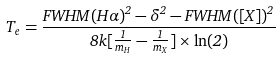Convert formula to latex. <formula><loc_0><loc_0><loc_500><loc_500>T _ { e } = \frac { F W H M ( H \alpha ) ^ { 2 } - \delta ^ { 2 } - F W H M ( [ X ] ) ^ { 2 } } { 8 k [ \frac { 1 } { m _ { H } } - \frac { 1 } { m _ { X } } ] \times \ln ( 2 ) }</formula> 